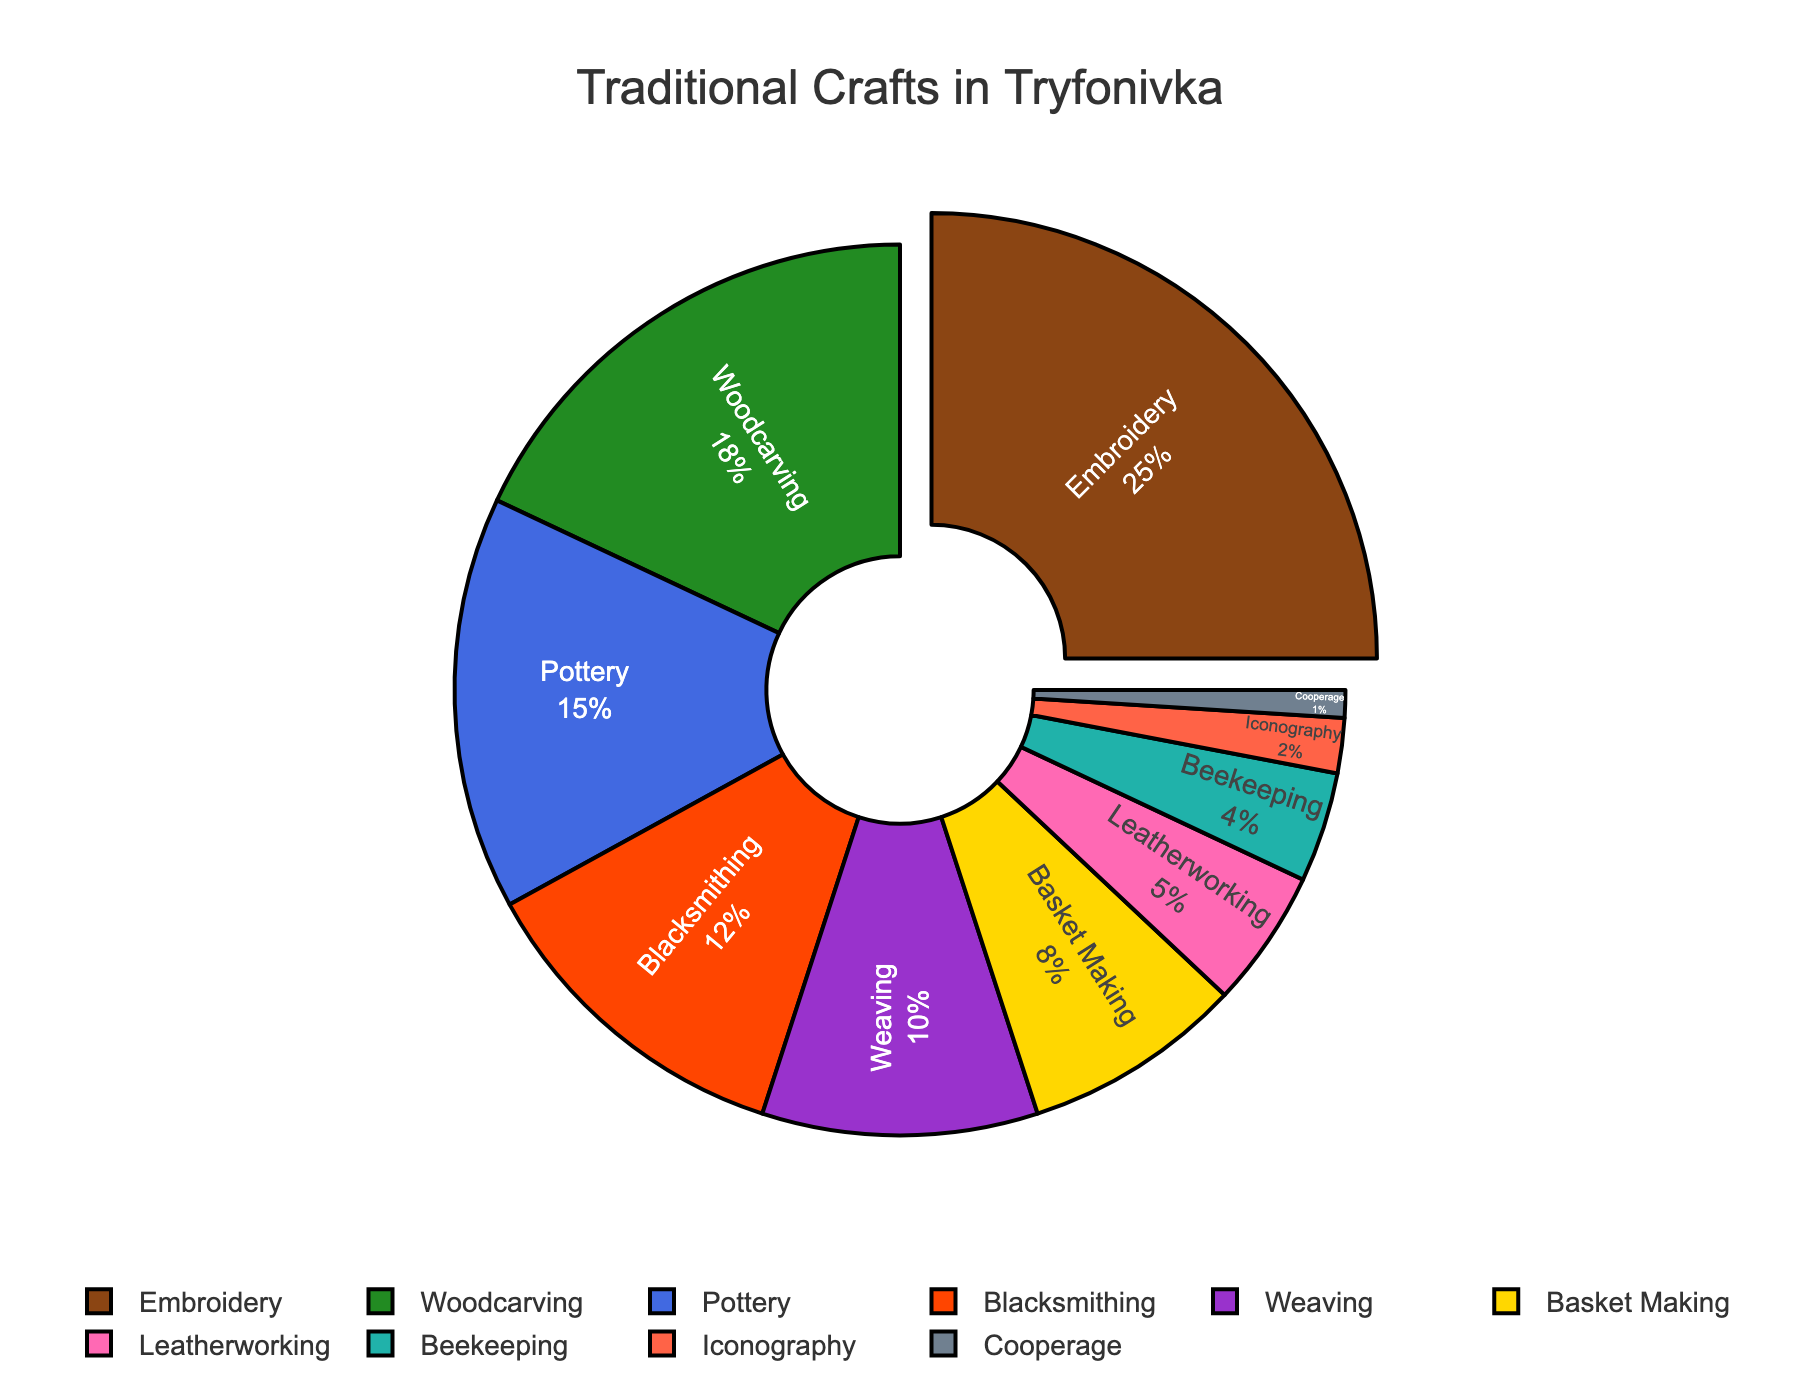What percentage of villagers practiced weaving and basket making combined? First, find the percentage for weaving (10%) and basket making (8%). Add these percentages together: 10% + 8% = 18%.
Answer: 18% Which traditional craft has the highest percentage and what is that percentage? Look for the craft with the largest segment in the pie chart. Embroidery has the highest percentage, which is 25%.
Answer: Embroidery, 25% How many crafts have a percentage of 5% or less? Identify the segments equal to or below 5%: Leatherworking (5%), Beekeeping (4%), Iconography (2%), Cooperage (1%). There are four such crafts.
Answer: 4 What is the difference in percentage between woodcarving and blacksmithing? The percentage for woodcarving is 18% and for blacksmithing is 12%. Subtract the smaller percentage from the larger one: 18% - 12% = 6%.
Answer: 6% Which traditional craft occupies the smallest portion of the pie chart? Find the craft with the smallest segment. Cooperage has the smallest portion at 1%.
Answer: Cooperage Compare the percentage of crafts practiced in pottery and beekeeping. Which one is greater and by how much? Pottery has a percentage of 15%, beekeeping has 4%. Subtract the smaller percentage from the larger one: 15% - 4% = 11%.
Answer: Pottery, 11% If you sum the percentages of all crafts that are not pulled out, what is the total? The only pulled-out segment is embroidery at 25%. Subtract this from 100%: 100% - 25% = 75%.
Answer: 75% How do the percentages of embroidery and woodcarving together compare to that of all other crafts combined? Embroidery (25%) + woodcarving (18%) = 43%. The total for all other crafts is 100% - 43% = 57%. 57% is larger than 43%.
Answer: All other crafts, 57% 